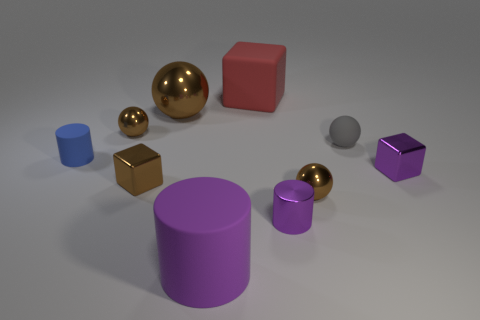There is another tiny thing that is the same shape as the tiny blue object; what material is it?
Give a very brief answer. Metal. Is the number of small brown balls that are on the left side of the big block less than the number of brown things?
Keep it short and to the point. Yes. There is a purple rubber thing; how many spheres are left of it?
Provide a succinct answer. 2. Is the shape of the big thing that is in front of the blue rubber object the same as the tiny brown metallic object that is behind the blue thing?
Make the answer very short. No. What is the shape of the rubber object that is both to the right of the big purple matte thing and on the left side of the small gray rubber thing?
Your response must be concise. Cube. The cube that is made of the same material as the large purple object is what size?
Your answer should be very brief. Large. Is the number of red objects less than the number of brown shiny cylinders?
Your response must be concise. No. The small ball that is in front of the small block that is right of the large matte thing behind the large purple cylinder is made of what material?
Give a very brief answer. Metal. Do the tiny brown block that is behind the small purple metallic cylinder and the red object that is to the left of the gray ball have the same material?
Ensure brevity in your answer.  No. There is a rubber thing that is both on the left side of the gray rubber sphere and behind the blue thing; what size is it?
Offer a terse response. Large. 